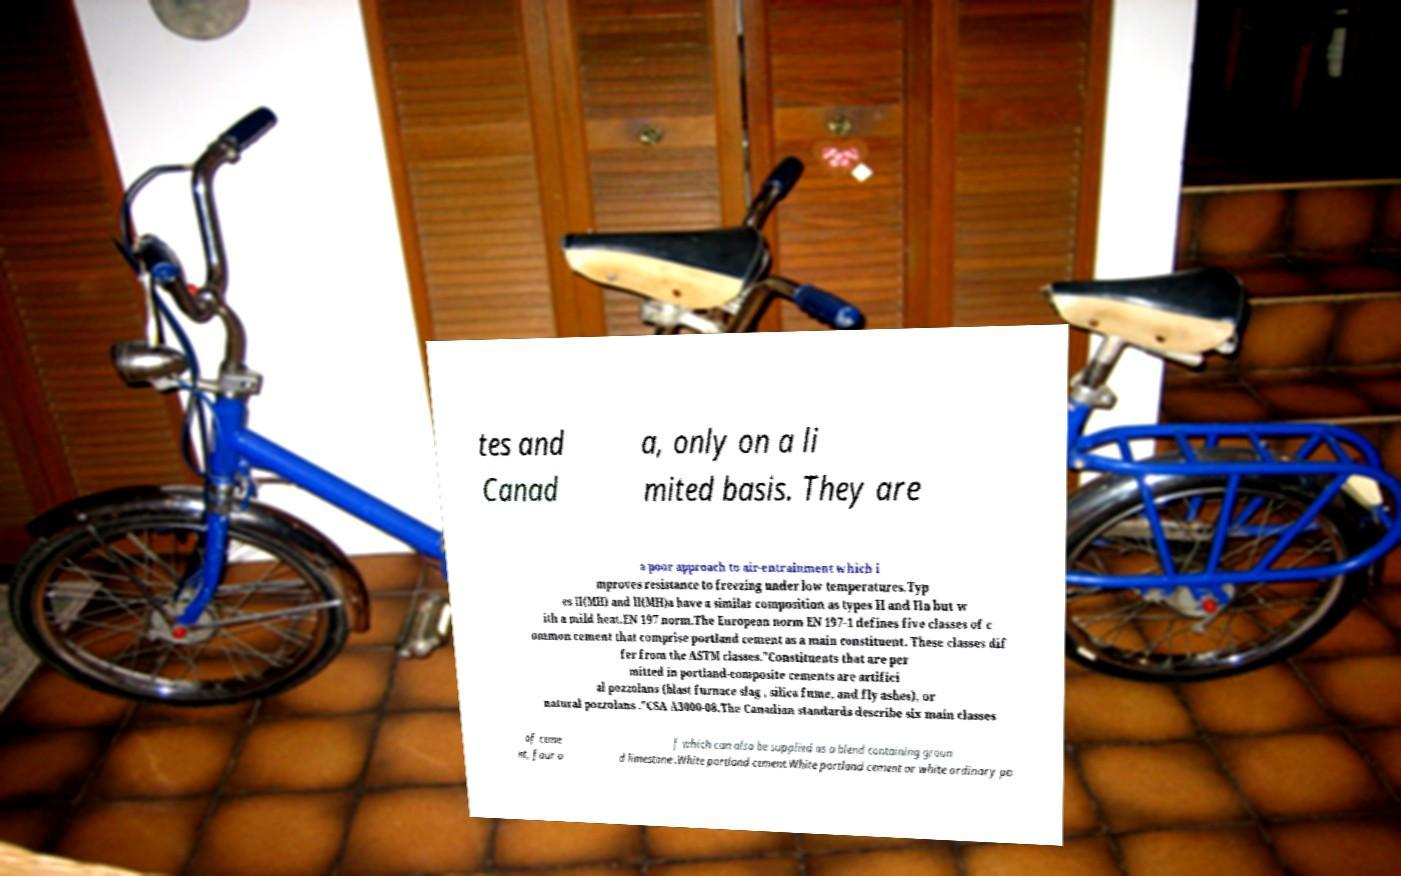Please identify and transcribe the text found in this image. tes and Canad a, only on a li mited basis. They are a poor approach to air-entrainment which i mproves resistance to freezing under low temperatures.Typ es II(MH) and II(MH)a have a similar composition as types II and IIa but w ith a mild heat.EN 197 norm.The European norm EN 197-1 defines five classes of c ommon cement that comprise portland cement as a main constituent. These classes dif fer from the ASTM classes."Constituents that are per mitted in portland-composite cements are artifici al pozzolans (blast furnace slag , silica fume, and fly ashes), or natural pozzolans ."CSA A3000-08.The Canadian standards describe six main classes of ceme nt, four o f which can also be supplied as a blend containing groun d limestone .White portland cement.White portland cement or white ordinary po 